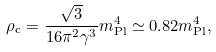<formula> <loc_0><loc_0><loc_500><loc_500>\rho _ { \text {c} } = \frac { \sqrt { 3 } } { 1 6 \pi ^ { 2 } \gamma ^ { 3 } } m ^ { 4 } _ { \text {Pl} } \simeq 0 . 8 2 m ^ { 4 } _ { \text {Pl} } ,</formula> 